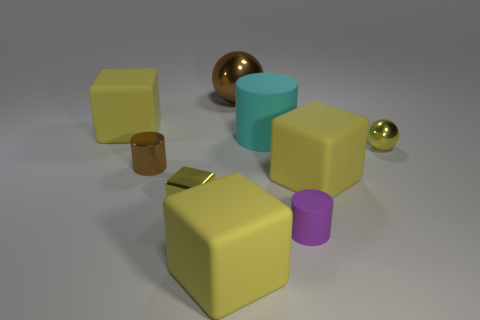Do the yellow metal object that is left of the purple matte cylinder and the cube that is right of the small purple cylinder have the same size?
Offer a terse response. No. What is the shape of the large cyan thing that is the same material as the purple thing?
Provide a short and direct response. Cylinder. Is there any other thing that is the same shape as the cyan object?
Keep it short and to the point. Yes. There is a cube that is in front of the tiny yellow metallic object that is in front of the tiny sphere that is in front of the cyan cylinder; what color is it?
Offer a terse response. Yellow. Is the number of big rubber cylinders that are to the left of the brown shiny ball less than the number of large cyan objects that are left of the large rubber cylinder?
Your response must be concise. No. Is the shape of the purple rubber object the same as the big cyan thing?
Ensure brevity in your answer.  Yes. How many cyan rubber cylinders have the same size as the purple matte cylinder?
Offer a terse response. 0. Are there fewer tiny purple cylinders that are to the right of the purple rubber cylinder than tiny matte spheres?
Offer a terse response. No. There is a yellow cube behind the big thing that is on the right side of the tiny matte cylinder; what size is it?
Offer a very short reply. Large. How many things are either big brown balls or small yellow spheres?
Provide a short and direct response. 2. 